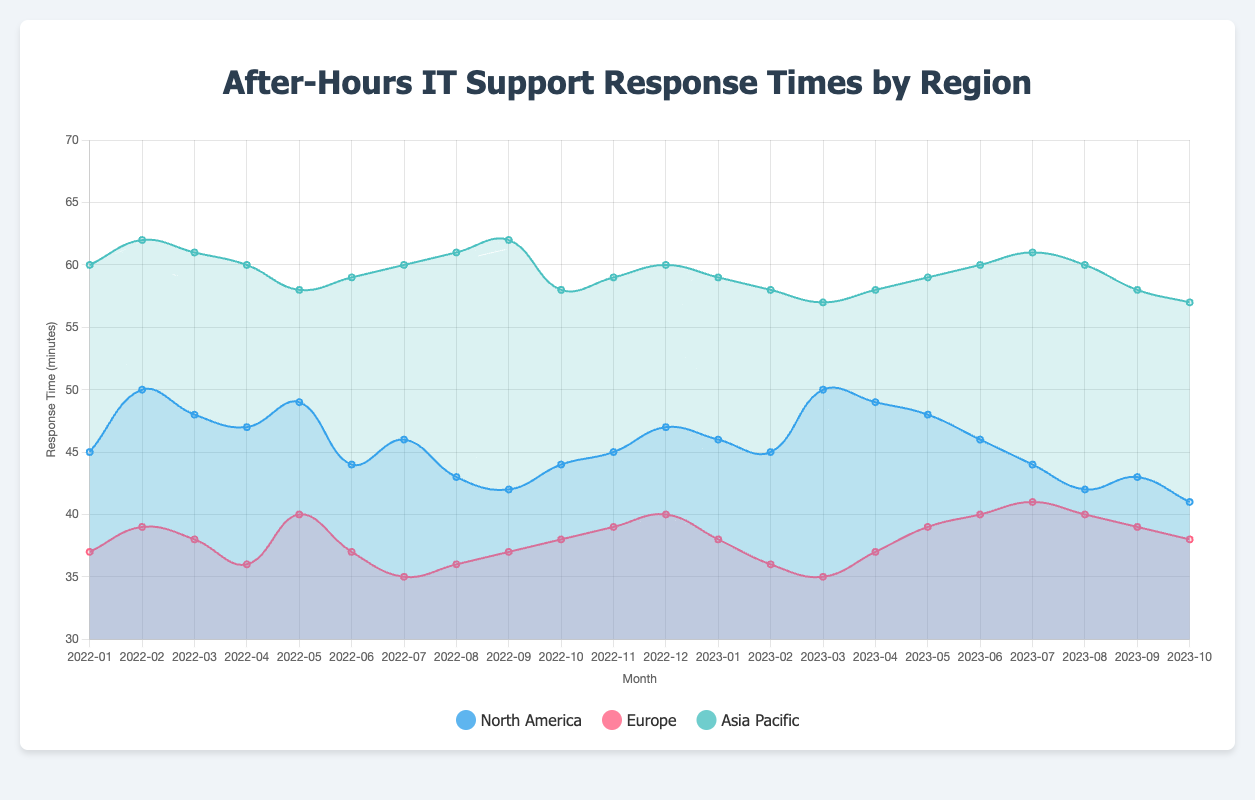Which region has the lowest average response time over the past two years? Calculate the average response time for each region. North America: (sum of monthly values / number of months) = (987 / 22) = 44.9 minutes. Europe: (834 / 22) = 37.9 minutes. Asia Pacific: (1306 / 22) = 59.4 minutes. Europe has the lowest average response time.
Answer: Europe During which months did North America's response time fall below 45 minutes? Identify months where the response time is less than 45 minutes in the North America data. The months are: Aug 2022 (43), Sep 2022 (42), Aug 2023 (42), Sep 2023 (43), Oct 2023 (41).
Answer: August 2022, September 2022, August 2023, September 2023, October 2023 Which region shows the most consistent response time over the two-year period? Determine the standard deviation of response times for each region. Lower standard deviation indicates more consistency. North America: standard deviation ≈ 2.74. Europe: standard deviation ≈ 1.94. Asia Pacific: standard deviation ≈ 1.68. Asia Pacific shows the most consistent response time.
Answer: Asia Pacific What is the overall trend in response time for North America? Track the response time changes over the past two years. Initially high and then fluctuating with a general downward trend, decreasing from 45 min (Jan 2022) to 41 min (Oct 2023).
Answer: General downward trend Which two months show the largest difference in response time for Europe? Identify the two months with the biggest difference in response time for Europe. Comparing all pairs, Jan 2022 (37) and Jul 2023 (41) show the largest difference of 4 minutes.
Answer: January 2022 and July 2023 On average, which region had the highest response time in 2023? Calculate the average response time for each region for the year 2023. North America: (sum of monthly values in 2023 / 10) = (460 / 10) = 46 minutes. Europe: (sum of monthly values in 2023 / 10) = (389 / 10) = 38.9 minutes. Asia Pacific: (sum of monthly values in 2023 / 10) = (583 / 10) = 58.3 minutes. Asia Pacific had the highest response time.
Answer: Asia Pacific What was the difference between the response time in North America and Europe in July 2023? Find the response times for North America (44) and Europe (41) in July 2023 and calculate the difference (44 - 41).
Answer: 3 minutes 